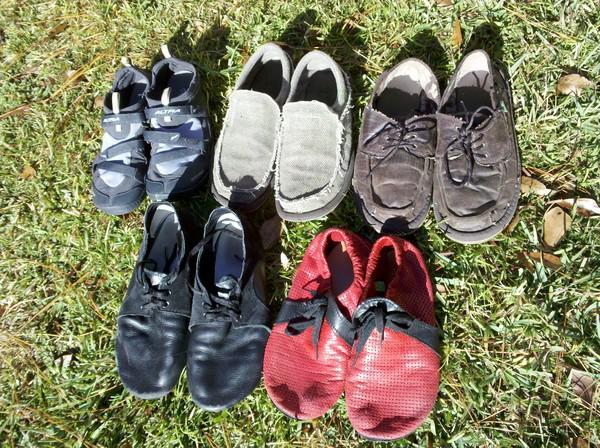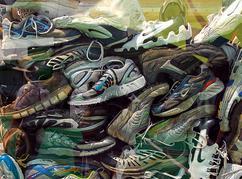The first image is the image on the left, the second image is the image on the right. Examine the images to the left and right. Is the description "An image shows two horizontal rows of shoes sitting on the grass." accurate? Answer yes or no. Yes. 